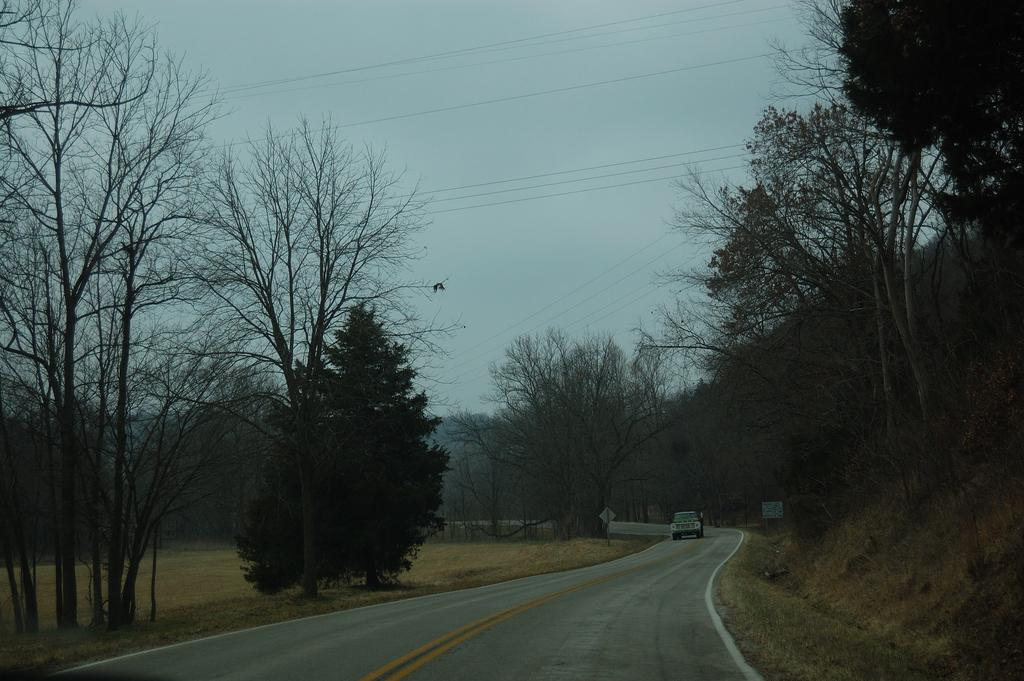What is the main feature of the image? There is a road in the image. What can be seen on the road? There is a vehicle on the road. What is surrounding the vehicle? There are trees around the vehicle. What type of dinner is being served on the road in the image? There is no dinner being served in the image; it features a road, a vehicle, and trees. 